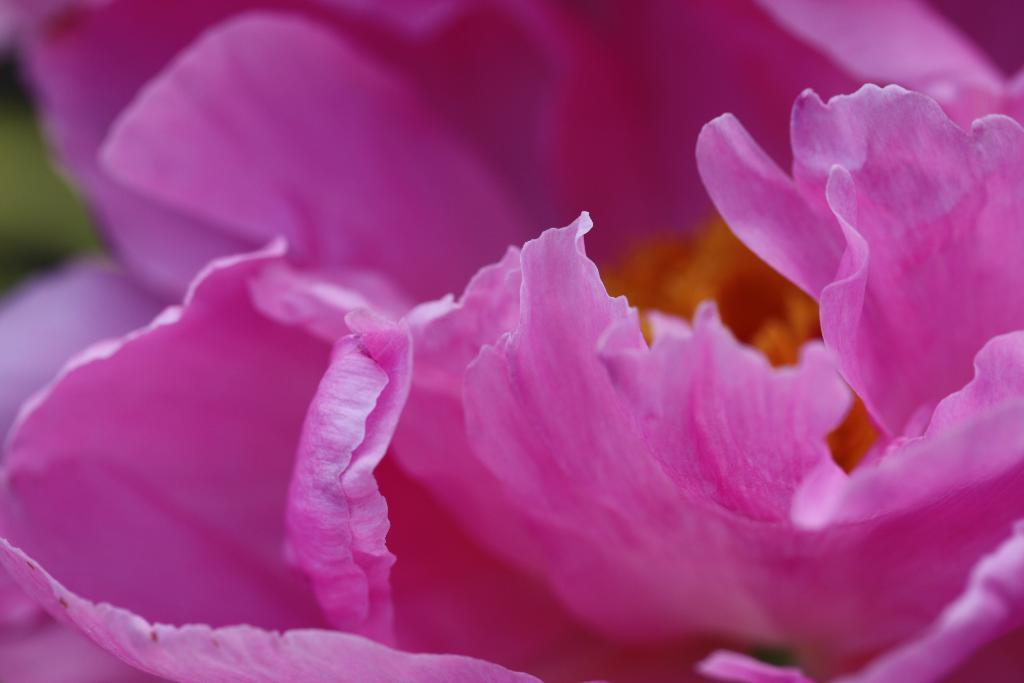What is the main subject of the picture? The main subject of the picture is a flower. Can you describe the color of the flower? The flower is pink in color. How many kittens are playing with the tramp in the picture? There are no kittens or tramps present in the image; it features a pink flower. 